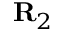<formula> <loc_0><loc_0><loc_500><loc_500>{ R } _ { 2 }</formula> 